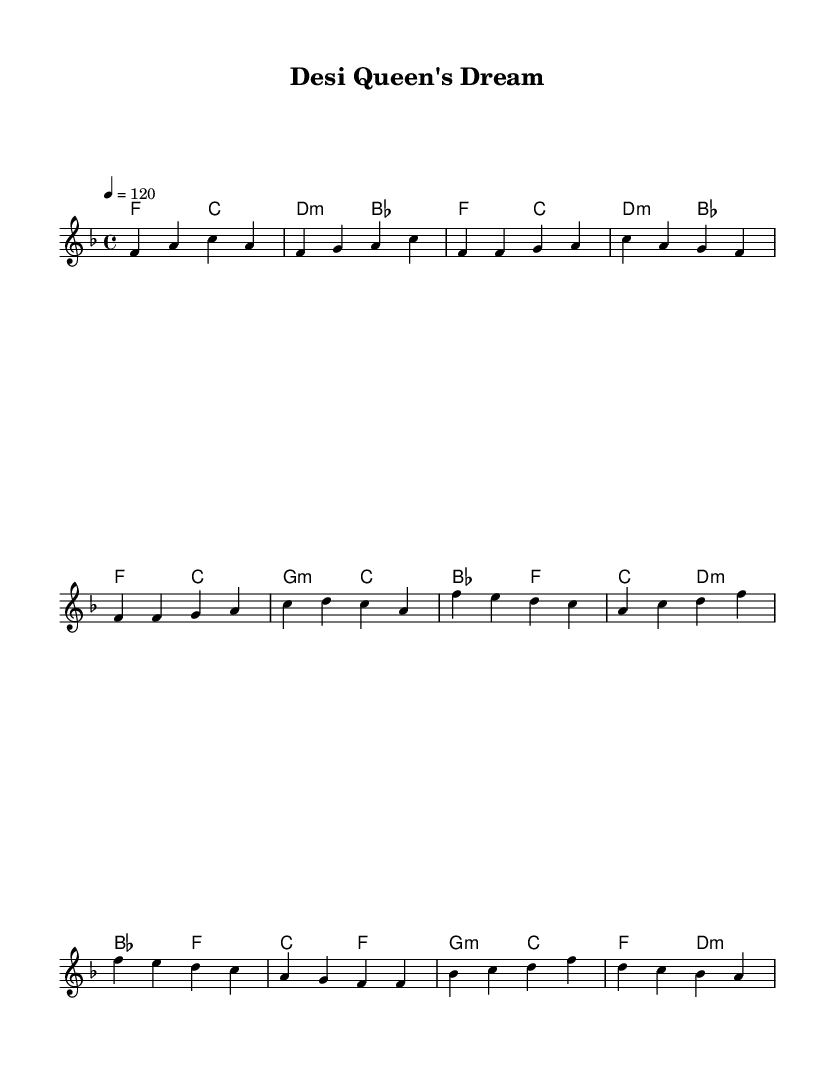What is the key signature of this music? The key signature is F major, which has one flat (B flat). This can be determined by looking at the key signature indicated at the beginning of the sheet music.
Answer: F major What is the time signature of this piece? The time signature is 4/4, as indicated at the beginning of the score. This means there are four beats in each measure, and the quarter note gets one beat.
Answer: 4/4 What is the tempo marking for this music? The tempo is marked as 120 beats per minute. This is found in the tempo indication at the beginning of the score, which specifies how fast the piece should be played.
Answer: 120 What is the main theme of this piece in relation to South Asian musical elements? The piece incorporates elements of South Asian music, such as the use of certain melodic structures and rhythmic patterns typical in South Asian genres, blended with the characteristics of R&B. This can be observed in the rhythmic patterns and the style of the melody.
Answer: Fusion of R&B and South Asian elements How many sections are there in the structure of this music? The score has three distinct sections: Intro, Verse, and Chorus, with a Bridge section towards the end. This can be seen in the layout of the melody and harmonies, indicating a clear structure throughout the piece.
Answer: Four sections What is the role of the harmonies in this piece? The harmonies provide a chordal backdrop that supports the melody, establishing the emotional and tonal framework of the piece. This is evident from the chord progression which complements the melodic line throughout the various sections.
Answer: Supportive backdrop 